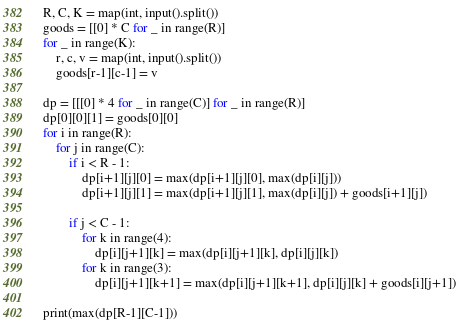Convert code to text. <code><loc_0><loc_0><loc_500><loc_500><_Python_>R, C, K = map(int, input().split())
goods = [[0] * C for _ in range(R)]
for _ in range(K):
    r, c, v = map(int, input().split())
    goods[r-1][c-1] = v

dp = [[[0] * 4 for _ in range(C)] for _ in range(R)]
dp[0][0][1] = goods[0][0]
for i in range(R):
    for j in range(C):
        if i < R - 1:
            dp[i+1][j][0] = max(dp[i+1][j][0], max(dp[i][j]))
            dp[i+1][j][1] = max(dp[i+1][j][1], max(dp[i][j]) + goods[i+1][j])
        
        if j < C - 1:
            for k in range(4):
                dp[i][j+1][k] = max(dp[i][j+1][k], dp[i][j][k])
            for k in range(3):
                dp[i][j+1][k+1] = max(dp[i][j+1][k+1], dp[i][j][k] + goods[i][j+1])

print(max(dp[R-1][C-1]))</code> 